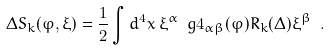<formula> <loc_0><loc_0><loc_500><loc_500>\Delta S _ { k } ( \varphi , \xi ) = \frac { 1 } { 2 } \int d ^ { 4 } x \, \xi ^ { \alpha } \ g 4 _ { \alpha \beta } ( \varphi ) R _ { k } ( \Delta ) \xi ^ { \beta } \ .</formula> 